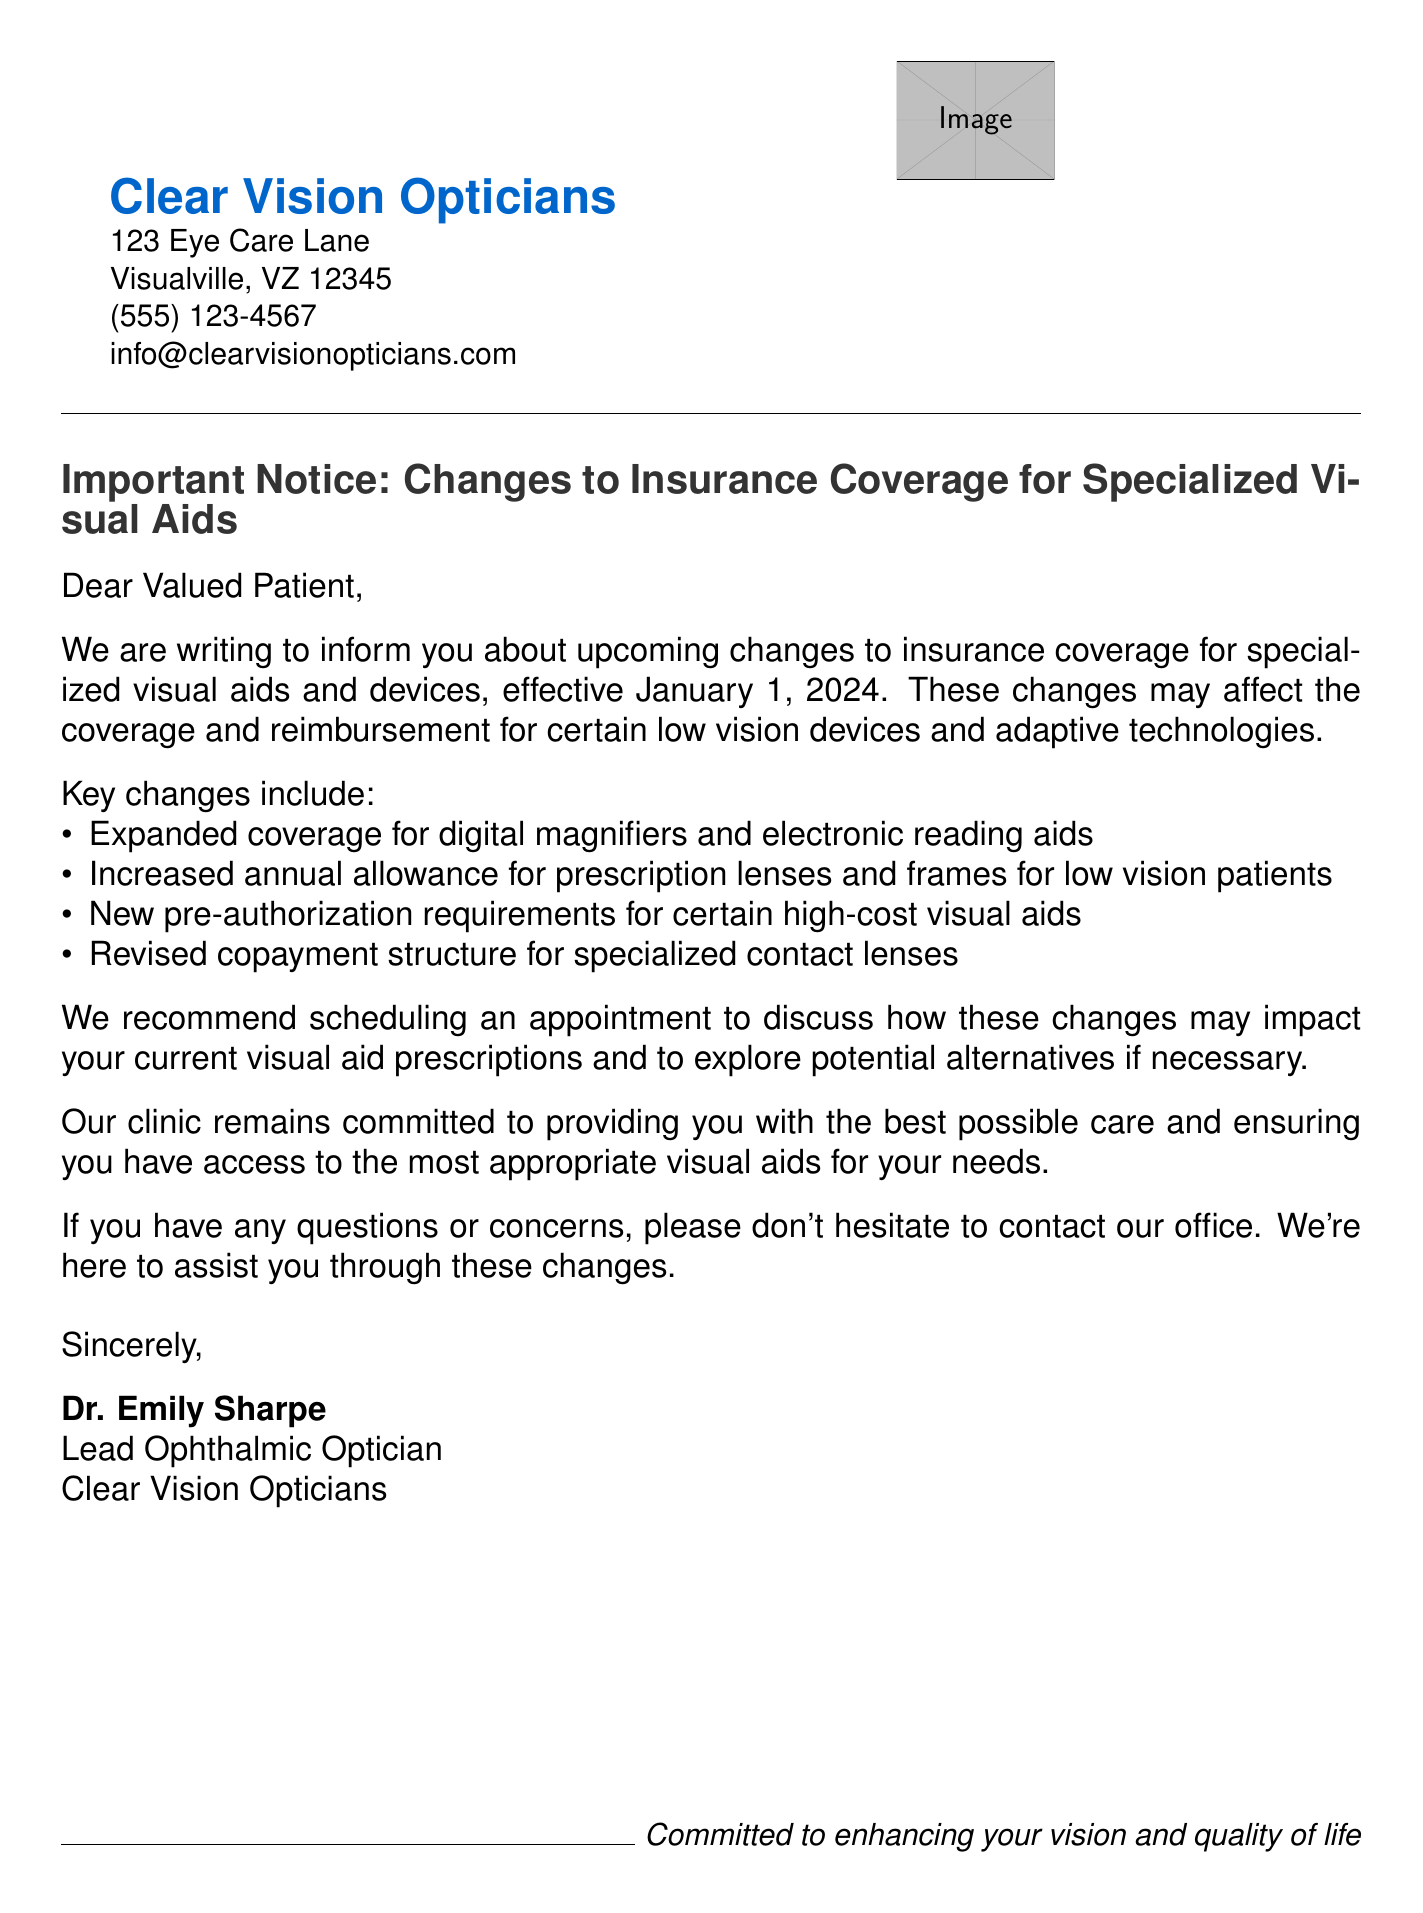What is the effective date of the changes? The effective date of the changes is specified in the document as January 1, 2024.
Answer: January 1, 2024 Who is the sender of the notice? The sender of the notice is mentioned at the end of the document as Dr. Emily Sharpe.
Answer: Dr. Emily Sharpe What type of devices will have expanded coverage? The document notes that expanded coverage is for digital magnifiers and electronic reading aids.
Answer: digital magnifiers and electronic reading aids What new requirement is introduced for high-cost visual aids? The document states that there are new pre-authorization requirements for certain high-cost visual aids.
Answer: pre-authorization requirements How can patients better understand the impact of the changes on their prescriptions? The document suggests that patients should schedule an appointment to discuss the impact.
Answer: scheduling an appointment What is the name of the clinic? The clinic’s name is mentioned in the header of the document as Clear Vision Opticians.
Answer: Clear Vision Opticians What has increased according to the insurance changes? The changes mentioned an increased annual allowance for prescription lenses and frames.
Answer: increased annual allowance What is the primary purpose of this notice? The purpose of the notice is to inform patients about changes to insurance coverage for specialized visual aids.
Answer: inform patients about changes to insurance coverage 